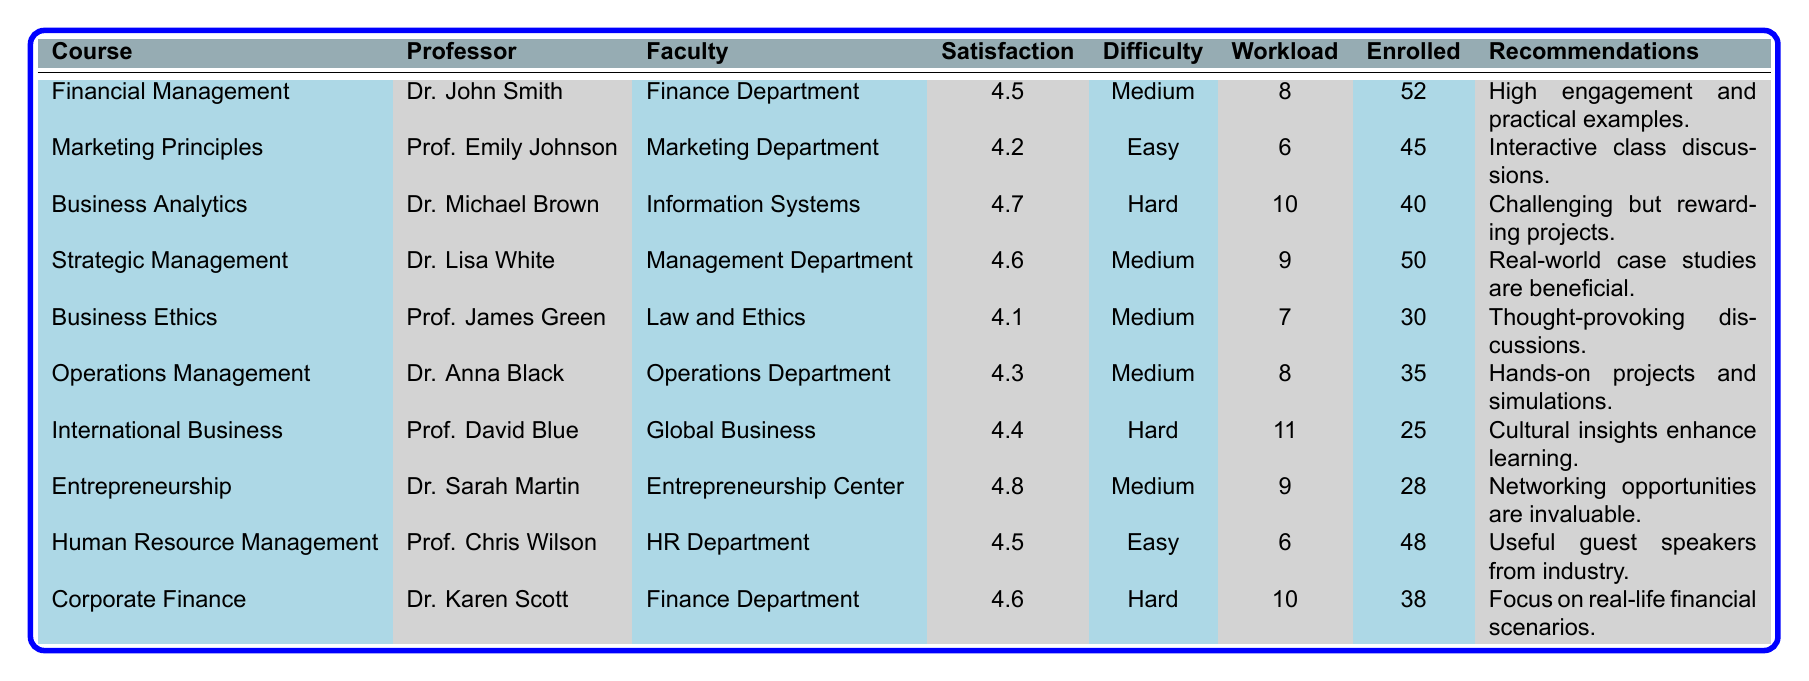What is the highest satisfaction rating among the courses listed? The table shows various satisfaction ratings for each course. Scanning through the ratings, "Entrepreneurship" has the highest rating of 4.8.
Answer: 4.8 Which course has the lowest satisfaction rating? By examining the satisfaction ratings in the table, "Business Ethics" has the lowest satisfaction rating at 4.1.
Answer: 4.1 How many students are enrolled in the "Corporate Finance" course? The table lists the number of students enrolled in each course. For "Corporate Finance," the enrollment is 38 students.
Answer: 38 What is the average workload for the courses categorized as "Medium" difficulty? The courses with "Medium" difficulty are Financial Management, Strategic Management, Operations Management, Entrepreneurship, and Human Resource Management. Their workloads are 8, 9, 8, 9, and 6 hours respectively. The average is (8 + 9 + 8 + 9 + 6) / 5 = 8.
Answer: 8 Is "International Business" a course with a difficulty level of "Easy"? The difficulty level for "International Business" is listed as "Hard" in the table. Thus, it is not categorized as "Easy."
Answer: No How many courses have a satisfaction rating of 4.5 or higher? The courses with satisfaction ratings of 4.5 or higher are: Financial Management (4.5), Business Analytics (4.7), Strategic Management (4.6), Entrepreneurship (4.8), Corporate Finance (4.6), and Human Resource Management (4.5). This totals to 6 courses.
Answer: 6 What is the total number of students enrolled across all courses? To find the total number of students, add the individual enrollments from the table: 52 + 45 + 40 + 50 + 30 + 35 + 25 + 28 + 48 + 38 = 413.
Answer: 413 Which course has the longest average workload, and what is that workload? The courses are compared based on the average workload. "International Business" has the highest workload of 11 hours per week.
Answer: 11 Are there any courses taught by professors with the last name "Johnson"? The table shows that "Marketing Principles" is taught by Prof. Emily Johnson, hence, there is at least one course by a Johnson.
Answer: Yes How does the satisfaction rating of "Business Analytics" compare to "Marketing Principles"? The satisfaction rating for "Business Analytics" is 4.7 and for "Marketing Principles," it is 4.2. Thus, Business Analytics has a higher rating by 0.5.
Answer: 0.5 What is the difference in satisfaction ratings between "Entrepreneurship" and "Business Ethics"? The satisfaction rating for "Entrepreneurship" is 4.8, and for "Business Ethics," it is 4.1. The difference is 4.8 - 4.1 = 0.7.
Answer: 0.7 